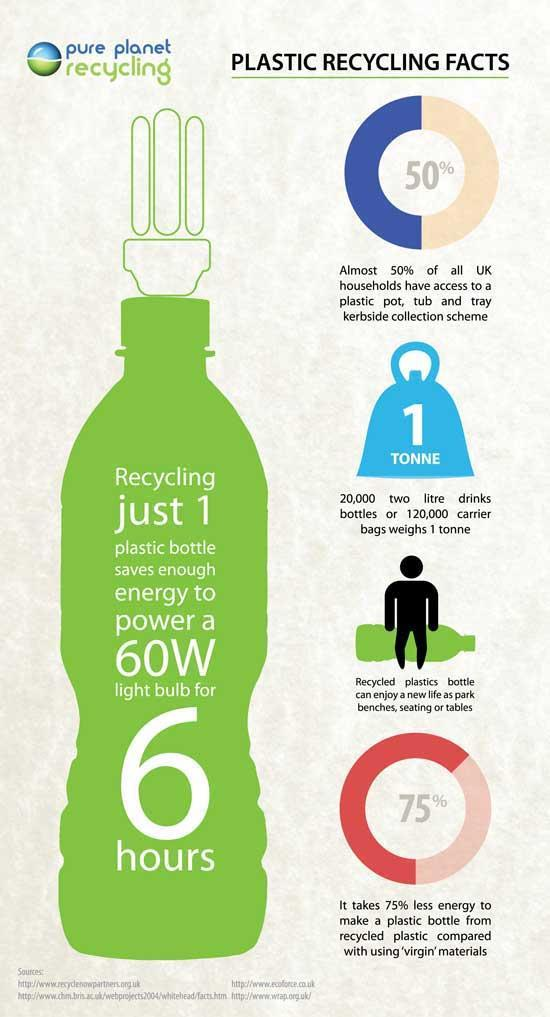What percentage of all UK households have no access to a plastic pot, tub & tray kerbside collection scheme?
Answer the question with a short phrase. 50% 